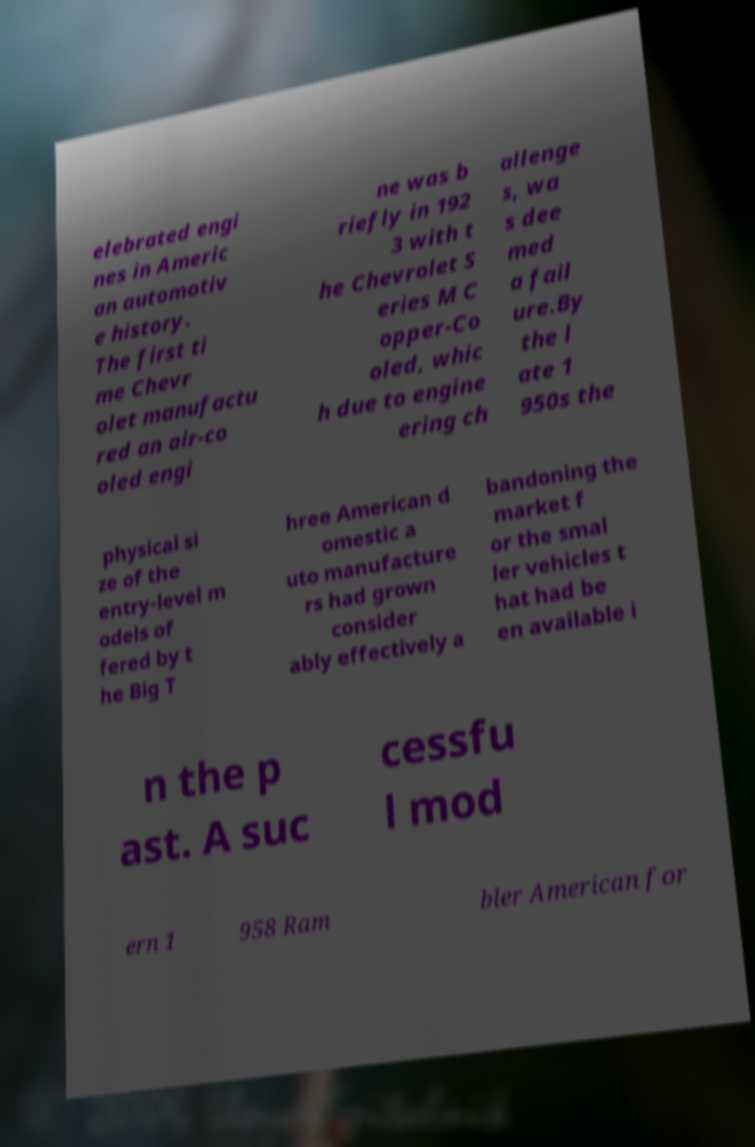Can you read and provide the text displayed in the image?This photo seems to have some interesting text. Can you extract and type it out for me? elebrated engi nes in Americ an automotiv e history. The first ti me Chevr olet manufactu red an air-co oled engi ne was b riefly in 192 3 with t he Chevrolet S eries M C opper-Co oled, whic h due to engine ering ch allenge s, wa s dee med a fail ure.By the l ate 1 950s the physical si ze of the entry-level m odels of fered by t he Big T hree American d omestic a uto manufacture rs had grown consider ably effectively a bandoning the market f or the smal ler vehicles t hat had be en available i n the p ast. A suc cessfu l mod ern 1 958 Ram bler American for 